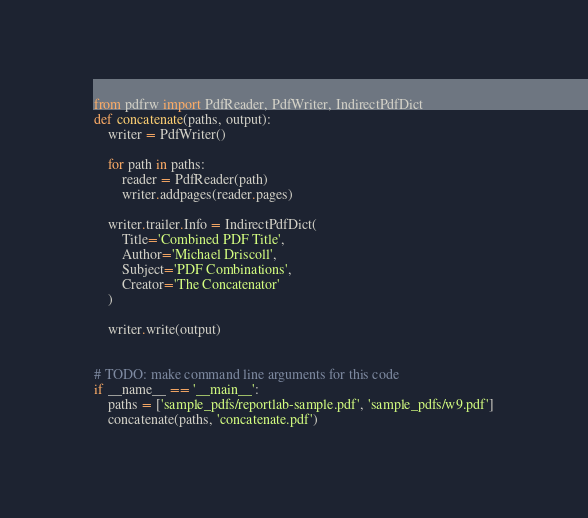Convert code to text. <code><loc_0><loc_0><loc_500><loc_500><_Python_>from pdfrw import PdfReader, PdfWriter, IndirectPdfDict
def concatenate(paths, output):
    writer = PdfWriter()
    
    for path in paths:
        reader = PdfReader(path)
        writer.addpages(reader.pages)
        
    writer.trailer.Info = IndirectPdfDict(
        Title='Combined PDF Title',
        Author='Michael Driscoll',
        Subject='PDF Combinations',
        Creator='The Concatenator'
    )
        
    writer.write(output)


# TODO: make command line arguments for this code
if __name__ == '__main__':
    paths = ['sample_pdfs/reportlab-sample.pdf', 'sample_pdfs/w9.pdf']
    concatenate(paths, 'concatenate.pdf')</code> 